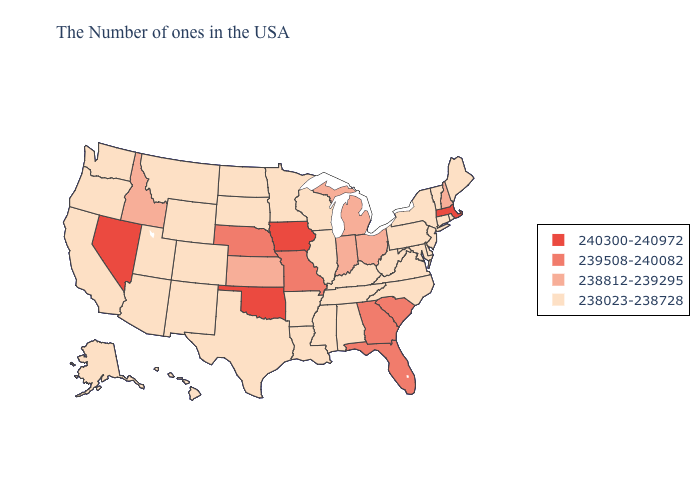Name the states that have a value in the range 238812-239295?
Write a very short answer. New Hampshire, Ohio, Michigan, Indiana, Kansas, Idaho. Which states hav the highest value in the West?
Be succinct. Nevada. Does Michigan have a higher value than Indiana?
Concise answer only. No. Does North Dakota have the highest value in the MidWest?
Concise answer only. No. What is the value of New York?
Short answer required. 238023-238728. What is the lowest value in the Northeast?
Concise answer only. 238023-238728. How many symbols are there in the legend?
Quick response, please. 4. What is the value of Connecticut?
Write a very short answer. 238023-238728. How many symbols are there in the legend?
Concise answer only. 4. What is the value of Washington?
Write a very short answer. 238023-238728. Which states hav the highest value in the Northeast?
Quick response, please. Massachusetts. Does the first symbol in the legend represent the smallest category?
Short answer required. No. Name the states that have a value in the range 238812-239295?
Give a very brief answer. New Hampshire, Ohio, Michigan, Indiana, Kansas, Idaho. Does the map have missing data?
Answer briefly. No. What is the value of Rhode Island?
Short answer required. 238023-238728. 